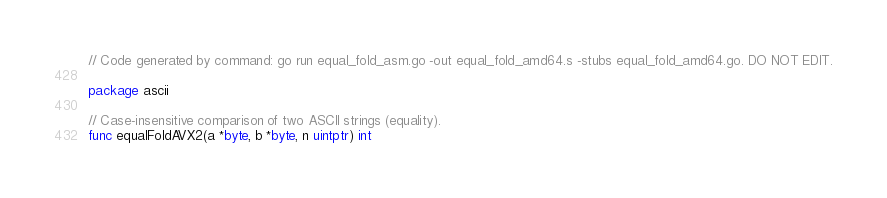Convert code to text. <code><loc_0><loc_0><loc_500><loc_500><_Go_>// Code generated by command: go run equal_fold_asm.go -out equal_fold_amd64.s -stubs equal_fold_amd64.go. DO NOT EDIT.

package ascii

// Case-insensitive comparison of two ASCII strings (equality).
func equalFoldAVX2(a *byte, b *byte, n uintptr) int
</code> 